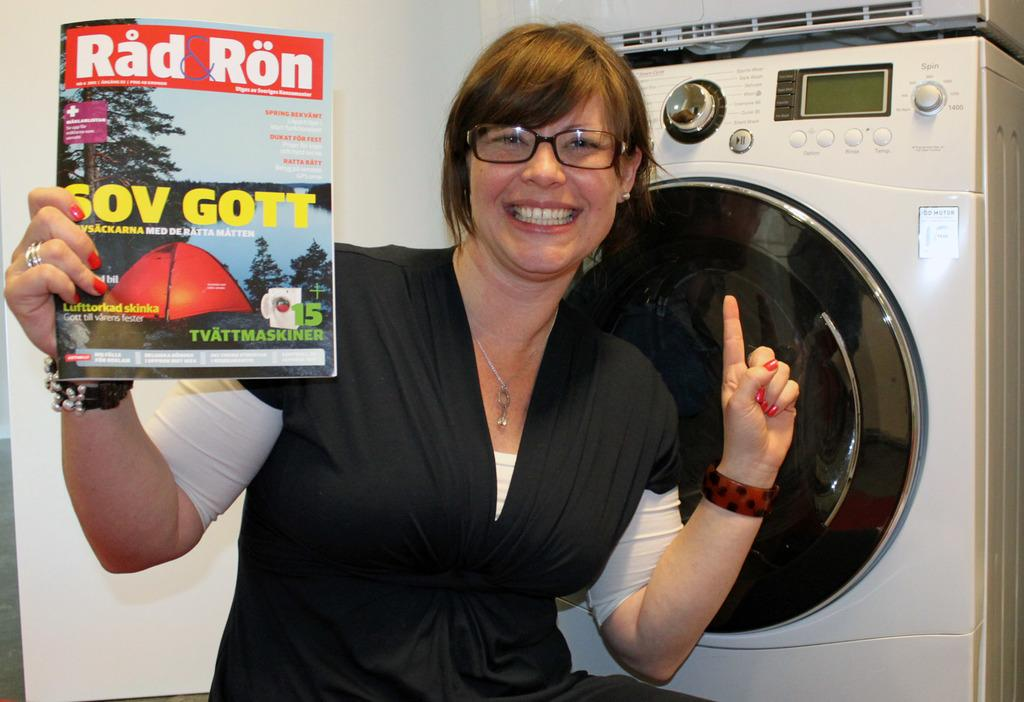<image>
Share a concise interpretation of the image provided. A woman wearing a black top smiles while holding a Rad Ron magazine in one hand. 